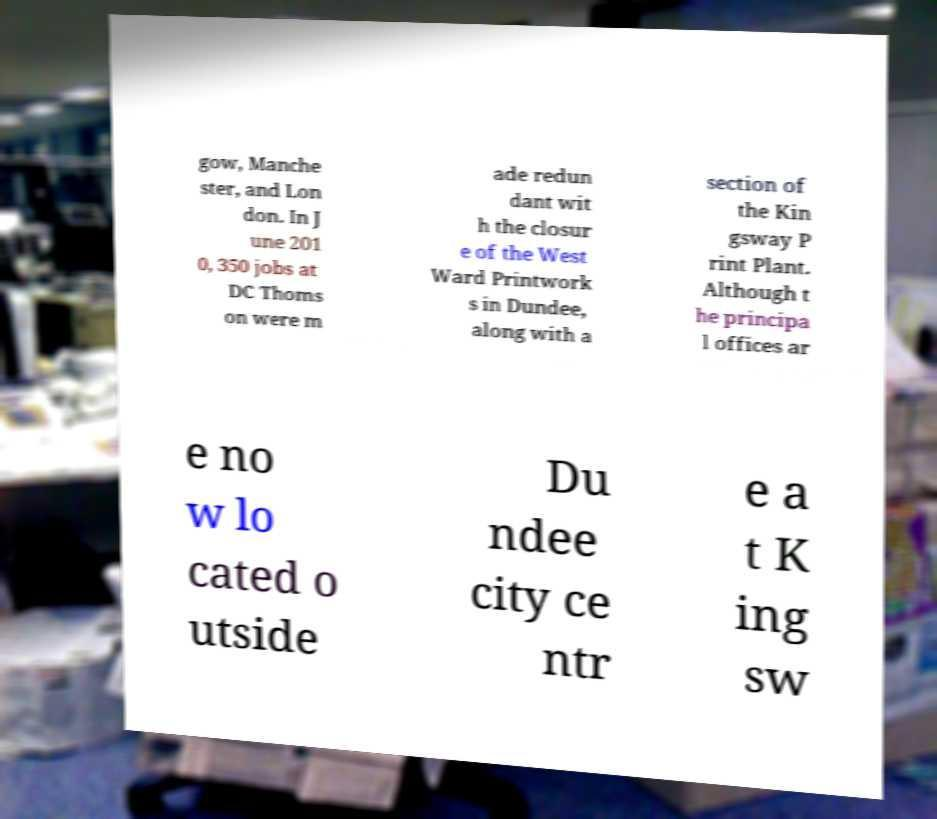Could you extract and type out the text from this image? gow, Manche ster, and Lon don. In J une 201 0, 350 jobs at DC Thoms on were m ade redun dant wit h the closur e of the West Ward Printwork s in Dundee, along with a section of the Kin gsway P rint Plant. Although t he principa l offices ar e no w lo cated o utside Du ndee city ce ntr e a t K ing sw 